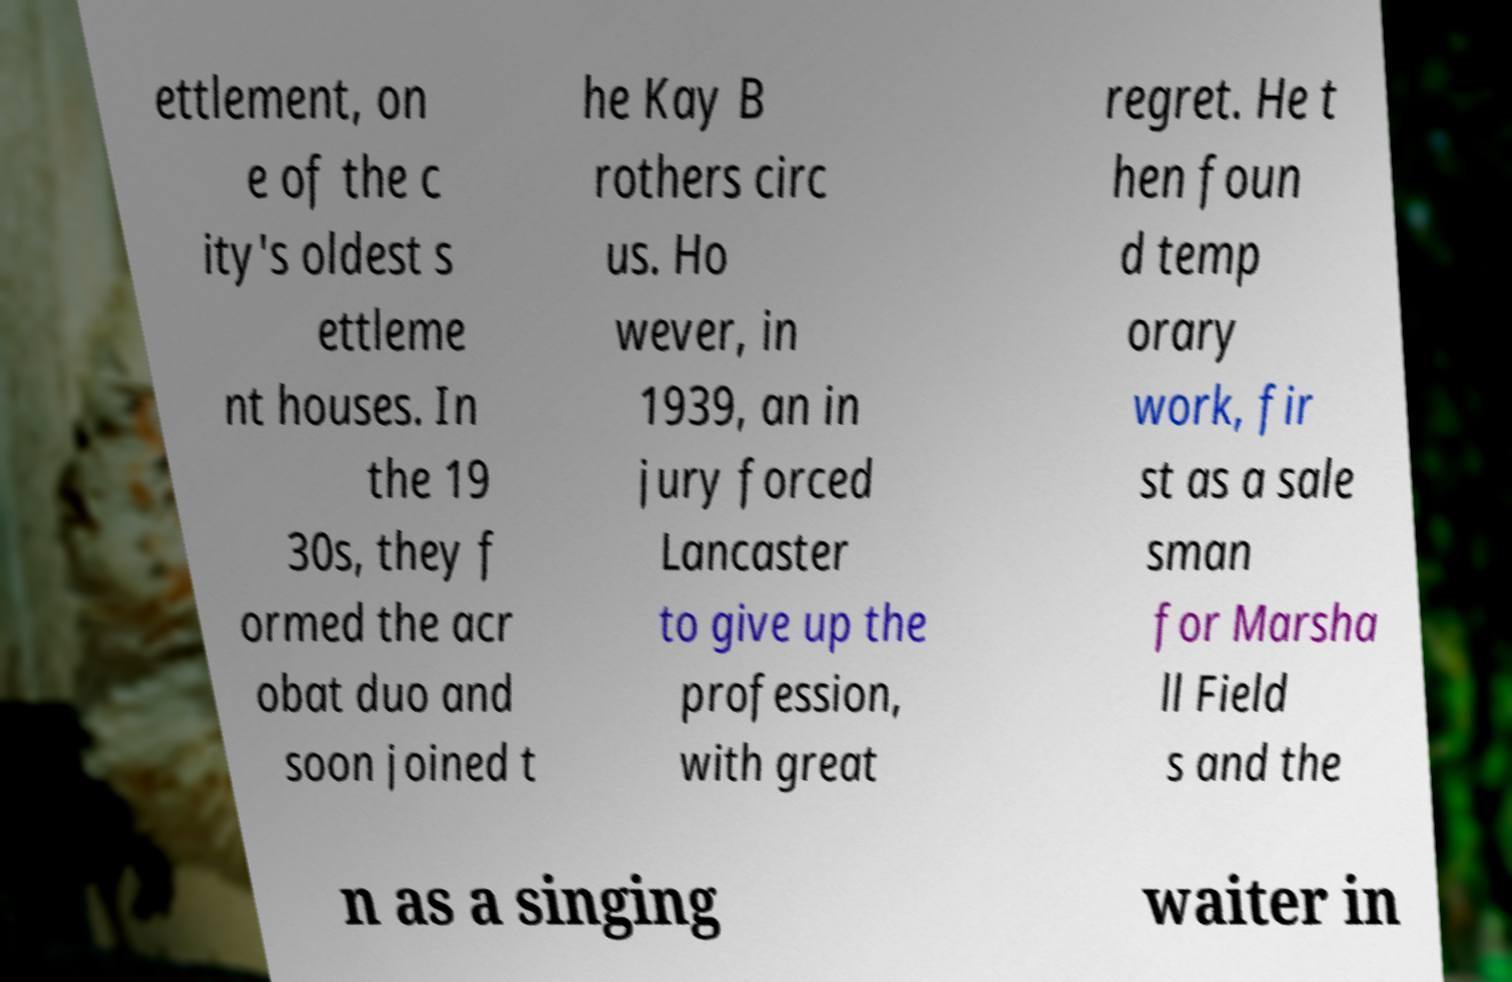Could you extract and type out the text from this image? ettlement, on e of the c ity's oldest s ettleme nt houses. In the 19 30s, they f ormed the acr obat duo and soon joined t he Kay B rothers circ us. Ho wever, in 1939, an in jury forced Lancaster to give up the profession, with great regret. He t hen foun d temp orary work, fir st as a sale sman for Marsha ll Field s and the n as a singing waiter in 